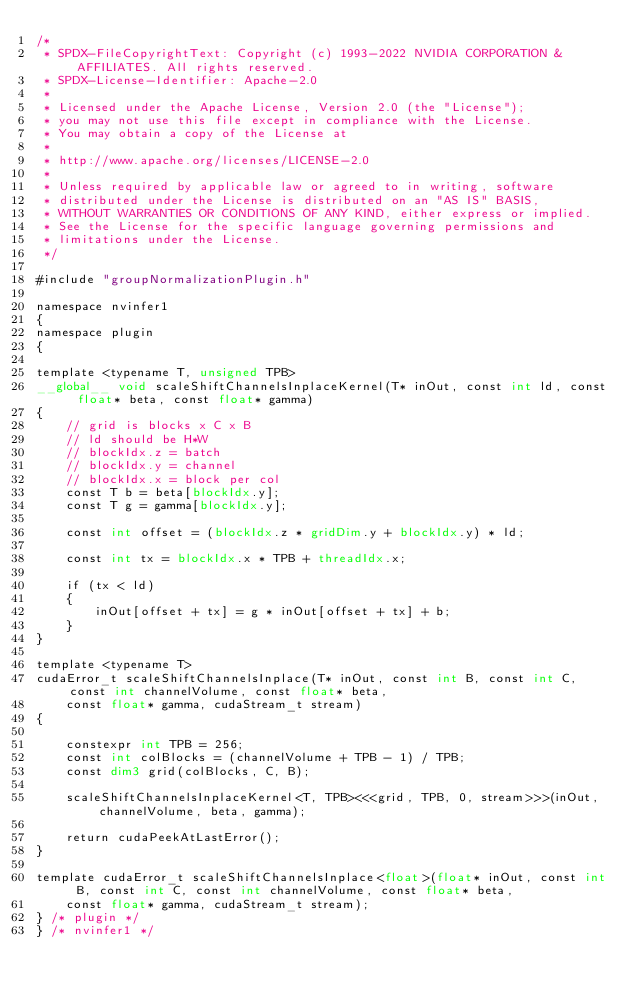<code> <loc_0><loc_0><loc_500><loc_500><_Cuda_>/*
 * SPDX-FileCopyrightText: Copyright (c) 1993-2022 NVIDIA CORPORATION & AFFILIATES. All rights reserved.
 * SPDX-License-Identifier: Apache-2.0
 *
 * Licensed under the Apache License, Version 2.0 (the "License");
 * you may not use this file except in compliance with the License.
 * You may obtain a copy of the License at
 *
 * http://www.apache.org/licenses/LICENSE-2.0
 *
 * Unless required by applicable law or agreed to in writing, software
 * distributed under the License is distributed on an "AS IS" BASIS,
 * WITHOUT WARRANTIES OR CONDITIONS OF ANY KIND, either express or implied.
 * See the License for the specific language governing permissions and
 * limitations under the License.
 */

#include "groupNormalizationPlugin.h"

namespace nvinfer1
{
namespace plugin
{

template <typename T, unsigned TPB>
__global__ void scaleShiftChannelsInplaceKernel(T* inOut, const int ld, const float* beta, const float* gamma)
{
    // grid is blocks x C x B
    // ld should be H*W
    // blockIdx.z = batch
    // blockIdx.y = channel
    // blockIdx.x = block per col
    const T b = beta[blockIdx.y];
    const T g = gamma[blockIdx.y];

    const int offset = (blockIdx.z * gridDim.y + blockIdx.y) * ld;

    const int tx = blockIdx.x * TPB + threadIdx.x;

    if (tx < ld)
    {
        inOut[offset + tx] = g * inOut[offset + tx] + b;
    }
}

template <typename T>
cudaError_t scaleShiftChannelsInplace(T* inOut, const int B, const int C, const int channelVolume, const float* beta,
    const float* gamma, cudaStream_t stream)
{

    constexpr int TPB = 256;
    const int colBlocks = (channelVolume + TPB - 1) / TPB;
    const dim3 grid(colBlocks, C, B);

    scaleShiftChannelsInplaceKernel<T, TPB><<<grid, TPB, 0, stream>>>(inOut, channelVolume, beta, gamma);

    return cudaPeekAtLastError();
}

template cudaError_t scaleShiftChannelsInplace<float>(float* inOut, const int B, const int C, const int channelVolume, const float* beta,
    const float* gamma, cudaStream_t stream);
} /* plugin */
} /* nvinfer1 */
</code> 